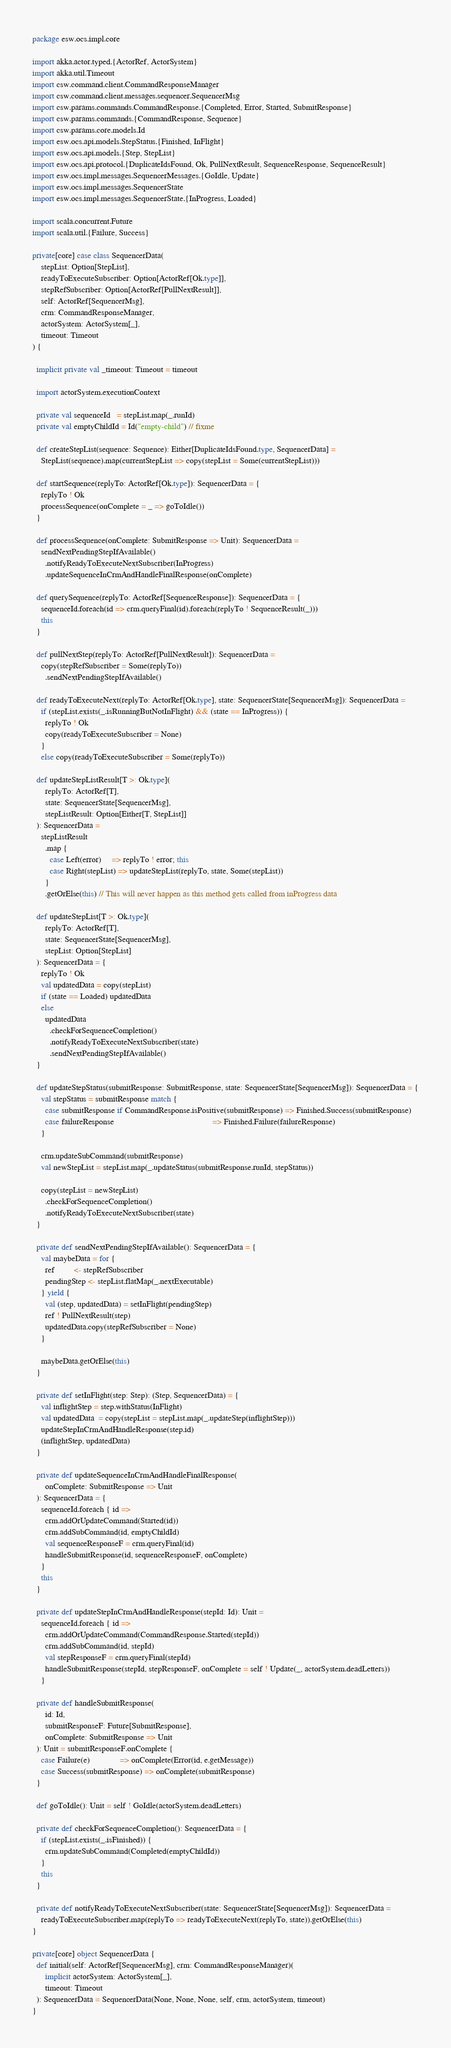Convert code to text. <code><loc_0><loc_0><loc_500><loc_500><_Scala_>package esw.ocs.impl.core

import akka.actor.typed.{ActorRef, ActorSystem}
import akka.util.Timeout
import csw.command.client.CommandResponseManager
import csw.command.client.messages.sequencer.SequencerMsg
import csw.params.commands.CommandResponse.{Completed, Error, Started, SubmitResponse}
import csw.params.commands.{CommandResponse, Sequence}
import csw.params.core.models.Id
import esw.ocs.api.models.StepStatus.{Finished, InFlight}
import esw.ocs.api.models.{Step, StepList}
import esw.ocs.api.protocol.{DuplicateIdsFound, Ok, PullNextResult, SequenceResponse, SequenceResult}
import esw.ocs.impl.messages.SequencerMessages.{GoIdle, Update}
import esw.ocs.impl.messages.SequencerState
import esw.ocs.impl.messages.SequencerState.{InProgress, Loaded}

import scala.concurrent.Future
import scala.util.{Failure, Success}

private[core] case class SequencerData(
    stepList: Option[StepList],
    readyToExecuteSubscriber: Option[ActorRef[Ok.type]],
    stepRefSubscriber: Option[ActorRef[PullNextResult]],
    self: ActorRef[SequencerMsg],
    crm: CommandResponseManager,
    actorSystem: ActorSystem[_],
    timeout: Timeout
) {

  implicit private val _timeout: Timeout = timeout

  import actorSystem.executionContext

  private val sequenceId   = stepList.map(_.runId)
  private val emptyChildId = Id("empty-child") // fixme

  def createStepList(sequence: Sequence): Either[DuplicateIdsFound.type, SequencerData] =
    StepList(sequence).map(currentStepList => copy(stepList = Some(currentStepList)))

  def startSequence(replyTo: ActorRef[Ok.type]): SequencerData = {
    replyTo ! Ok
    processSequence(onComplete = _ => goToIdle())
  }

  def processSequence(onComplete: SubmitResponse => Unit): SequencerData =
    sendNextPendingStepIfAvailable()
      .notifyReadyToExecuteNextSubscriber(InProgress)
      .updateSequenceInCrmAndHandleFinalResponse(onComplete)

  def querySequence(replyTo: ActorRef[SequenceResponse]): SequencerData = {
    sequenceId.foreach(id => crm.queryFinal(id).foreach(replyTo ! SequenceResult(_)))
    this
  }

  def pullNextStep(replyTo: ActorRef[PullNextResult]): SequencerData =
    copy(stepRefSubscriber = Some(replyTo))
      .sendNextPendingStepIfAvailable()

  def readyToExecuteNext(replyTo: ActorRef[Ok.type], state: SequencerState[SequencerMsg]): SequencerData =
    if (stepList.exists(_.isRunningButNotInFlight) && (state == InProgress)) {
      replyTo ! Ok
      copy(readyToExecuteSubscriber = None)
    }
    else copy(readyToExecuteSubscriber = Some(replyTo))

  def updateStepListResult[T >: Ok.type](
      replyTo: ActorRef[T],
      state: SequencerState[SequencerMsg],
      stepListResult: Option[Either[T, StepList]]
  ): SequencerData =
    stepListResult
      .map {
        case Left(error)     => replyTo ! error; this
        case Right(stepList) => updateStepList(replyTo, state, Some(stepList))
      }
      .getOrElse(this) // This will never happen as this method gets called from inProgress data

  def updateStepList[T >: Ok.type](
      replyTo: ActorRef[T],
      state: SequencerState[SequencerMsg],
      stepList: Option[StepList]
  ): SequencerData = {
    replyTo ! Ok
    val updatedData = copy(stepList)
    if (state == Loaded) updatedData
    else
      updatedData
        .checkForSequenceCompletion()
        .notifyReadyToExecuteNextSubscriber(state)
        .sendNextPendingStepIfAvailable()
  }

  def updateStepStatus(submitResponse: SubmitResponse, state: SequencerState[SequencerMsg]): SequencerData = {
    val stepStatus = submitResponse match {
      case submitResponse if CommandResponse.isPositive(submitResponse) => Finished.Success(submitResponse)
      case failureResponse                                              => Finished.Failure(failureResponse)
    }

    crm.updateSubCommand(submitResponse)
    val newStepList = stepList.map(_.updateStatus(submitResponse.runId, stepStatus))

    copy(stepList = newStepList)
      .checkForSequenceCompletion()
      .notifyReadyToExecuteNextSubscriber(state)
  }

  private def sendNextPendingStepIfAvailable(): SequencerData = {
    val maybeData = for {
      ref         <- stepRefSubscriber
      pendingStep <- stepList.flatMap(_.nextExecutable)
    } yield {
      val (step, updatedData) = setInFlight(pendingStep)
      ref ! PullNextResult(step)
      updatedData.copy(stepRefSubscriber = None)
    }

    maybeData.getOrElse(this)
  }

  private def setInFlight(step: Step): (Step, SequencerData) = {
    val inflightStep = step.withStatus(InFlight)
    val updatedData  = copy(stepList = stepList.map(_.updateStep(inflightStep)))
    updateStepInCrmAndHandleResponse(step.id)
    (inflightStep, updatedData)
  }

  private def updateSequenceInCrmAndHandleFinalResponse(
      onComplete: SubmitResponse => Unit
  ): SequencerData = {
    sequenceId.foreach { id =>
      crm.addOrUpdateCommand(Started(id))
      crm.addSubCommand(id, emptyChildId)
      val sequenceResponseF = crm.queryFinal(id)
      handleSubmitResponse(id, sequenceResponseF, onComplete)
    }
    this
  }

  private def updateStepInCrmAndHandleResponse(stepId: Id): Unit =
    sequenceId.foreach { id =>
      crm.addOrUpdateCommand(CommandResponse.Started(stepId))
      crm.addSubCommand(id, stepId)
      val stepResponseF = crm.queryFinal(stepId)
      handleSubmitResponse(stepId, stepResponseF, onComplete = self ! Update(_, actorSystem.deadLetters))
    }

  private def handleSubmitResponse(
      id: Id,
      submitResponseF: Future[SubmitResponse],
      onComplete: SubmitResponse => Unit
  ): Unit = submitResponseF.onComplete {
    case Failure(e)              => onComplete(Error(id, e.getMessage))
    case Success(submitResponse) => onComplete(submitResponse)
  }

  def goToIdle(): Unit = self ! GoIdle(actorSystem.deadLetters)

  private def checkForSequenceCompletion(): SequencerData = {
    if (stepList.exists(_.isFinished)) {
      crm.updateSubCommand(Completed(emptyChildId))
    }
    this
  }

  private def notifyReadyToExecuteNextSubscriber(state: SequencerState[SequencerMsg]): SequencerData =
    readyToExecuteSubscriber.map(replyTo => readyToExecuteNext(replyTo, state)).getOrElse(this)
}

private[core] object SequencerData {
  def initial(self: ActorRef[SequencerMsg], crm: CommandResponseManager)(
      implicit actorSystem: ActorSystem[_],
      timeout: Timeout
  ): SequencerData = SequencerData(None, None, None, self, crm, actorSystem, timeout)
}
</code> 